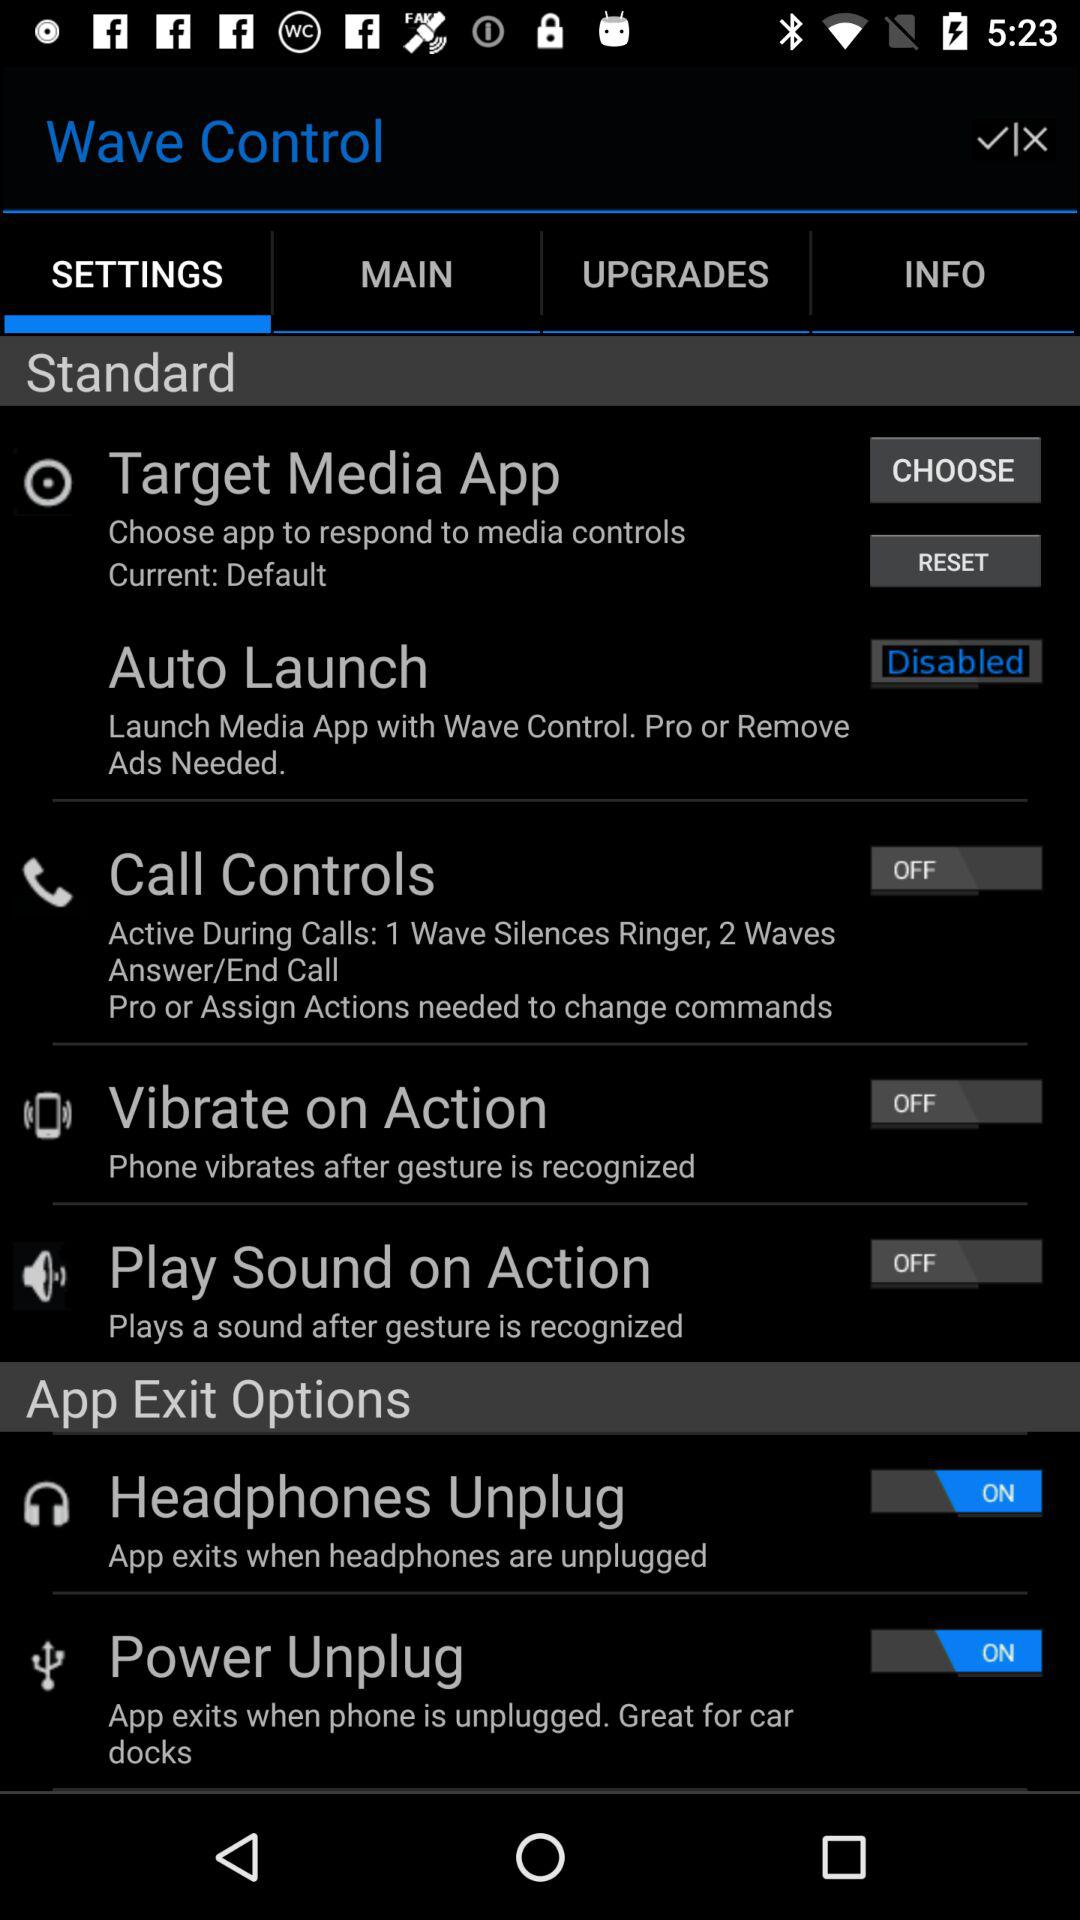Is there any option within the settings that's currently disabled? Yes, there are multiple settings that currently appear disabled, such as 'Auto Launch', 'Call Controls', 'Vibrate on Action', and 'Play Sound on Action' as indicated by their grey color and the 'OFF' position of their switches. 